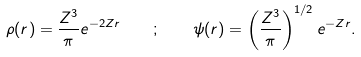Convert formula to latex. <formula><loc_0><loc_0><loc_500><loc_500>\rho ( r ) = \frac { Z ^ { 3 } } { \pi } e ^ { - 2 Z r } \quad ; \quad \psi ( r ) = \left ( \frac { Z ^ { 3 } } { \pi } \right ) ^ { 1 / 2 } e ^ { - Z r } .</formula> 